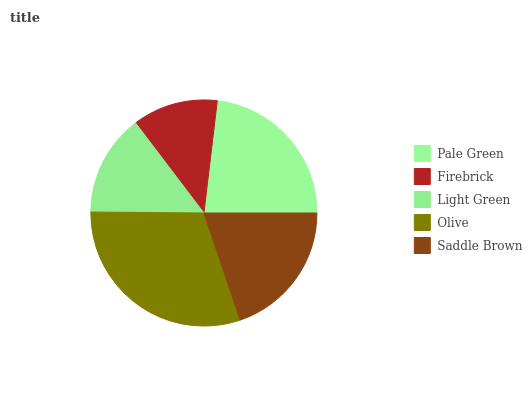Is Firebrick the minimum?
Answer yes or no. Yes. Is Olive the maximum?
Answer yes or no. Yes. Is Light Green the minimum?
Answer yes or no. No. Is Light Green the maximum?
Answer yes or no. No. Is Light Green greater than Firebrick?
Answer yes or no. Yes. Is Firebrick less than Light Green?
Answer yes or no. Yes. Is Firebrick greater than Light Green?
Answer yes or no. No. Is Light Green less than Firebrick?
Answer yes or no. No. Is Saddle Brown the high median?
Answer yes or no. Yes. Is Saddle Brown the low median?
Answer yes or no. Yes. Is Olive the high median?
Answer yes or no. No. Is Olive the low median?
Answer yes or no. No. 